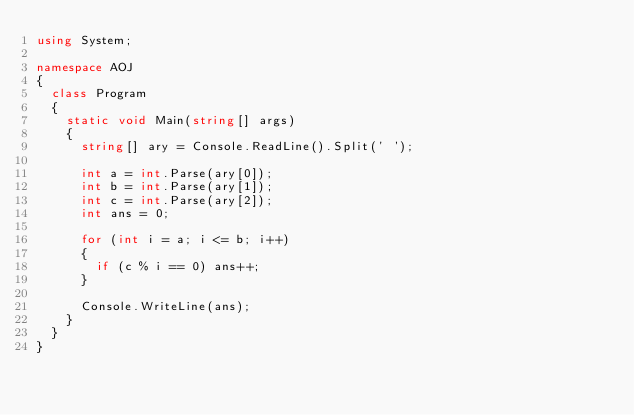<code> <loc_0><loc_0><loc_500><loc_500><_C#_>using System;

namespace AOJ
{
  class Program
  {
    static void Main(string[] args)
    {
      string[] ary = Console.ReadLine().Split(' ');

      int a = int.Parse(ary[0]);
      int b = int.Parse(ary[1]);
      int c = int.Parse(ary[2]);
      int ans = 0;

      for (int i = a; i <= b; i++)
      {
        if (c % i == 0) ans++;
      }

      Console.WriteLine(ans);
    }
  }
}</code> 